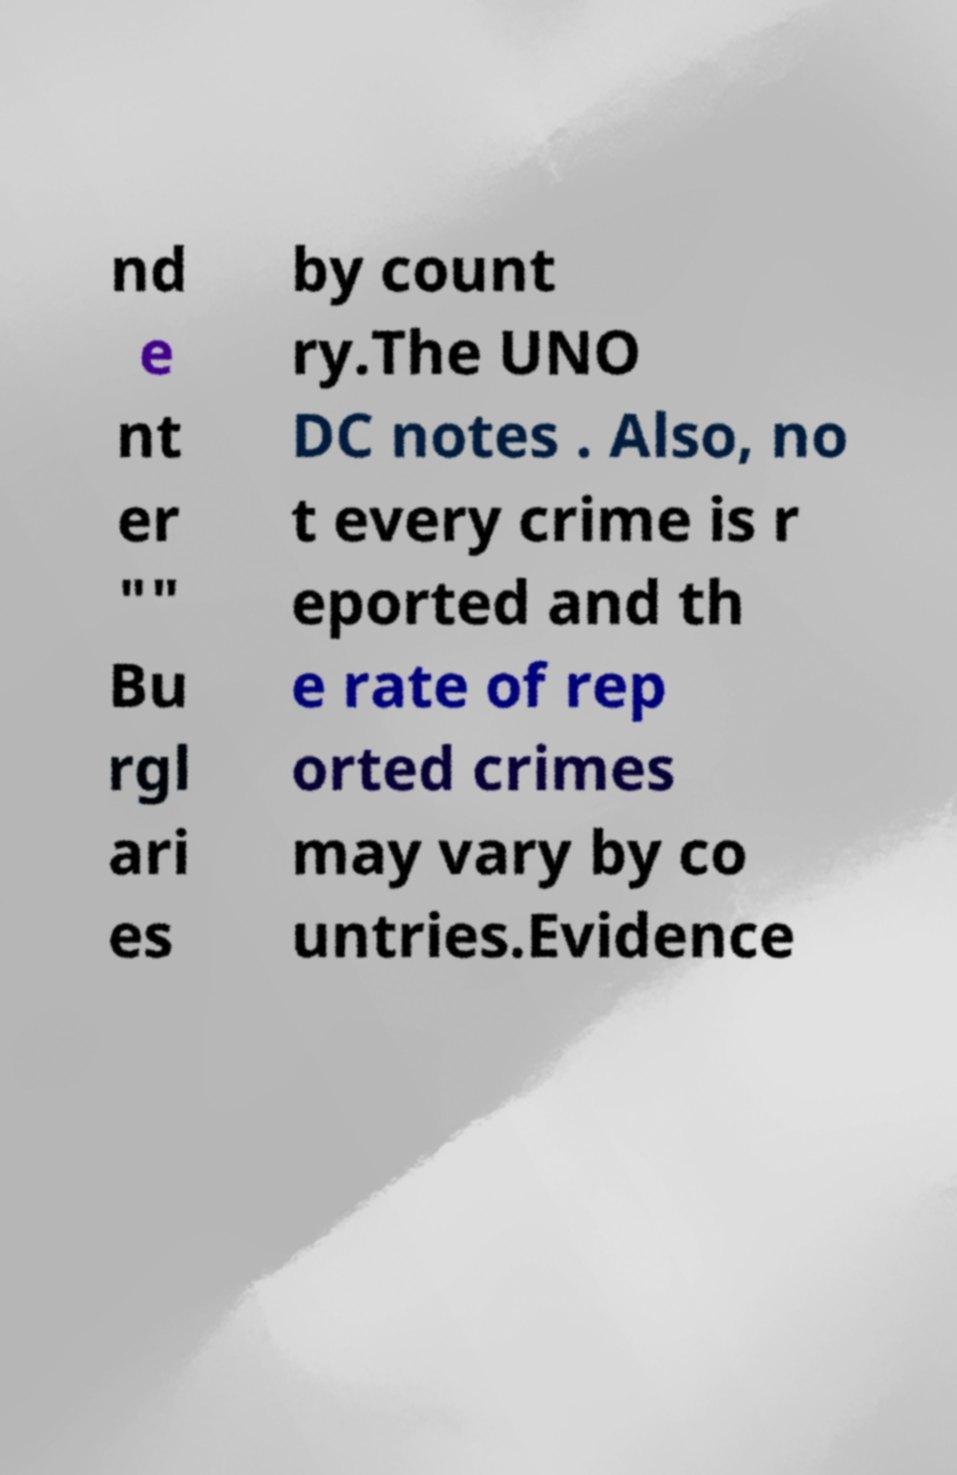Could you extract and type out the text from this image? nd e nt er "" Bu rgl ari es by count ry.The UNO DC notes . Also, no t every crime is r eported and th e rate of rep orted crimes may vary by co untries.Evidence 